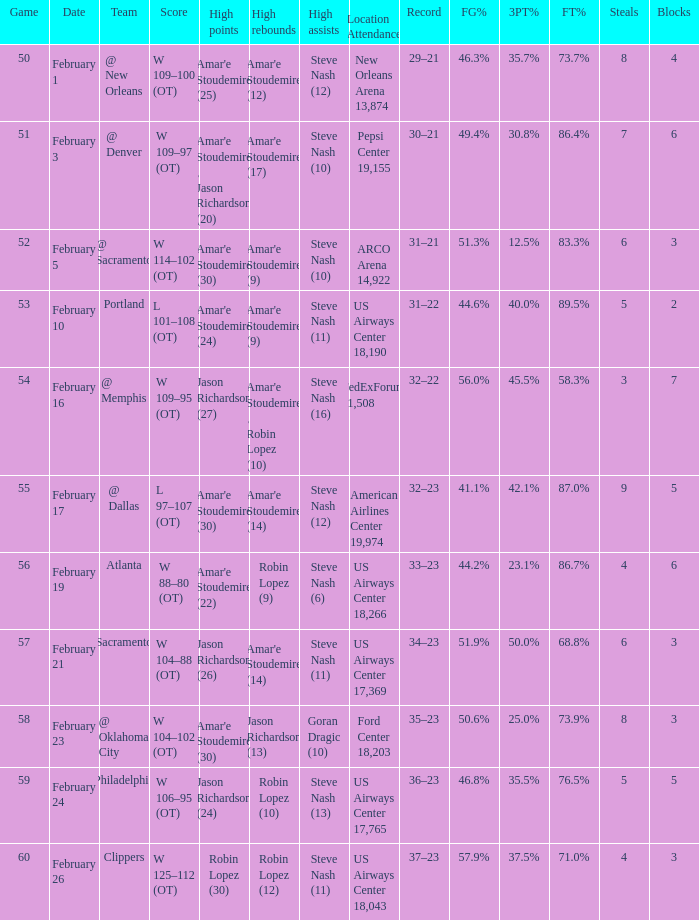Name the high points for pepsi center 19,155 Amar'e Stoudemire , Jason Richardson (20). 